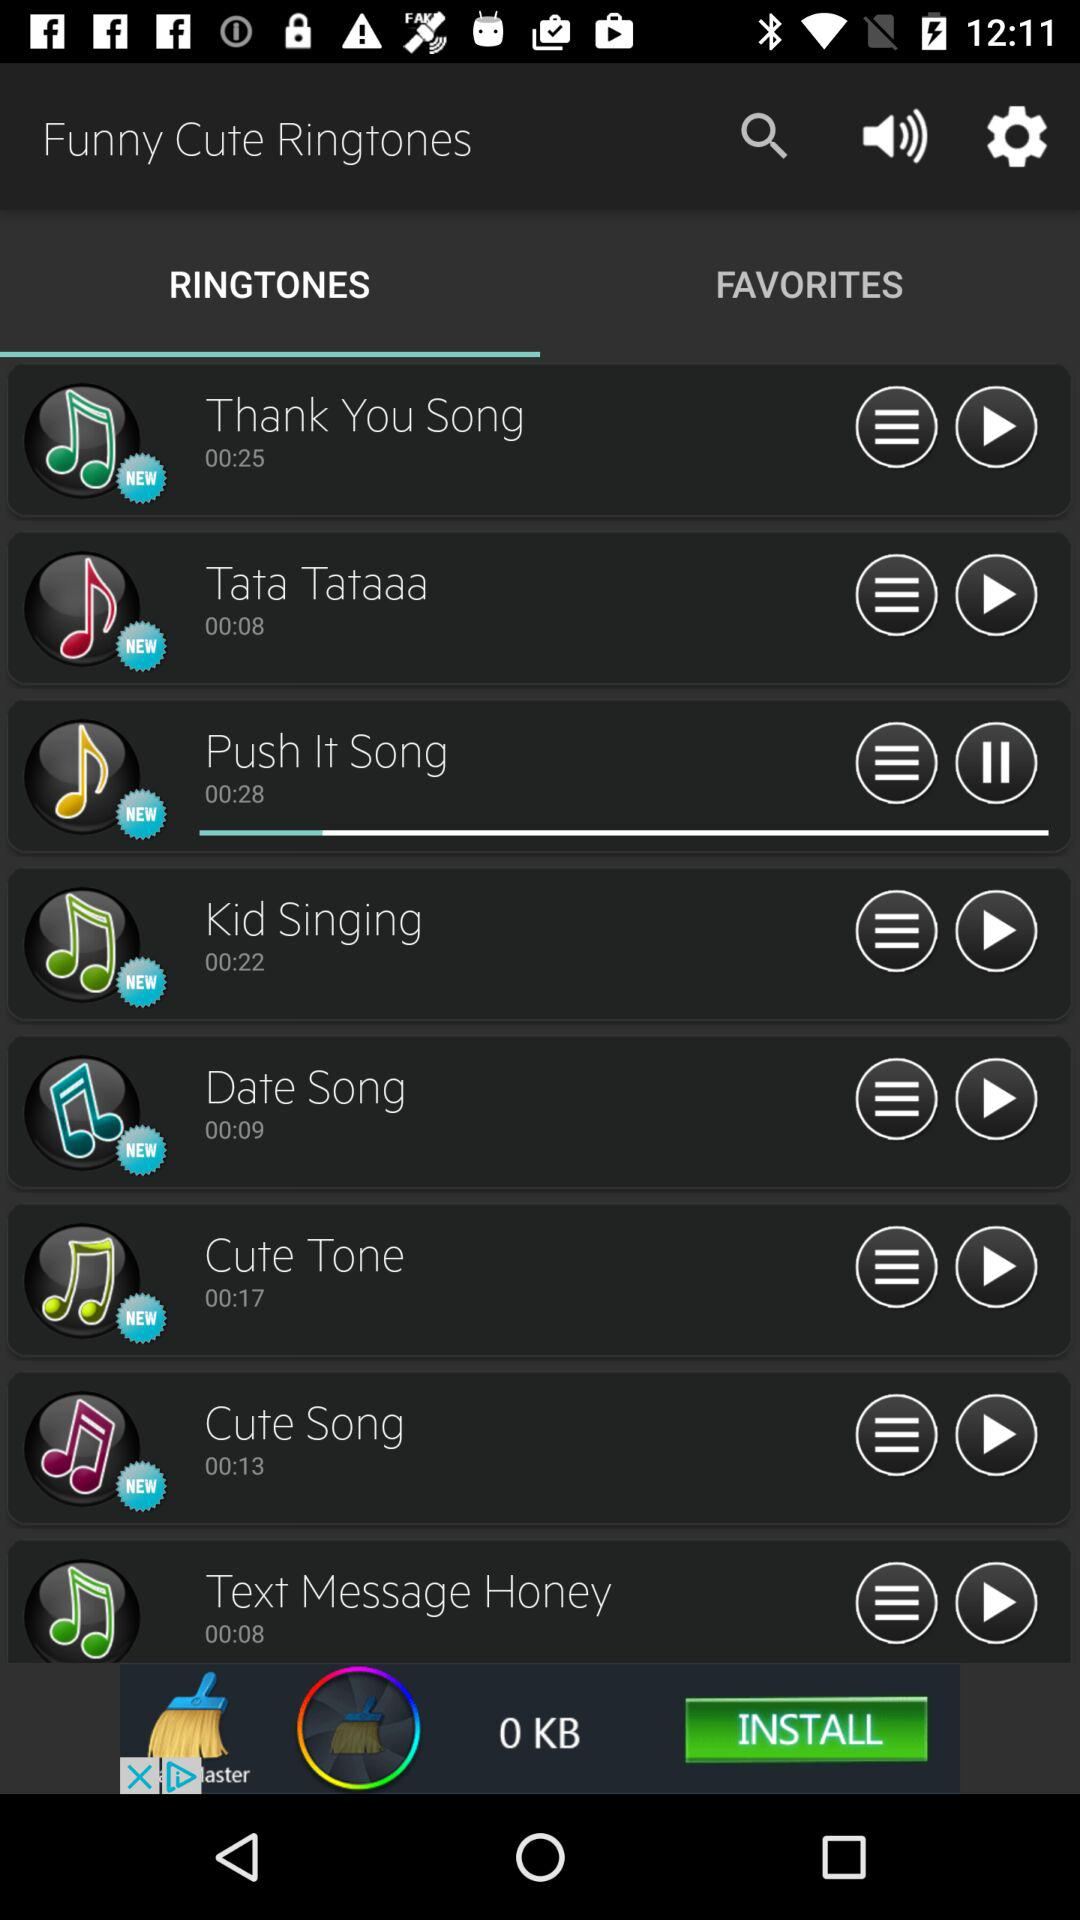What is the duration of the "Date Song" ringtone? The duration is 00:09 seconds. 